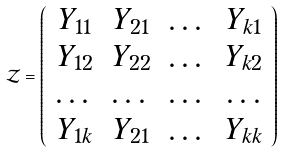Convert formula to latex. <formula><loc_0><loc_0><loc_500><loc_500>\mathcal { Z } = \left ( \begin{array} { c c c c } Y _ { 1 1 } & Y _ { 2 1 } & \dots & Y _ { k 1 } \\ Y _ { 1 2 } & Y _ { 2 2 } & \dots & Y _ { k 2 } \\ \dots & \dots & \dots & \dots \\ Y _ { 1 k } & Y _ { 2 1 } & \dots & Y _ { k k } \\ \end{array} \right )</formula> 